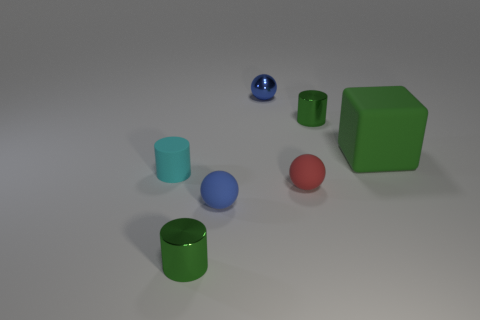What kind of materials do these objects look like they're made of, and how could that be determined visually? Visually, the objects appear to be made of a smooth, possibly plastic material, as indicated by their even matte surfaces and soft reflections. The way they reflect light without sharp glares or deep transparency suggests a solid and opaque material that could be commonly used in household items or toys. 